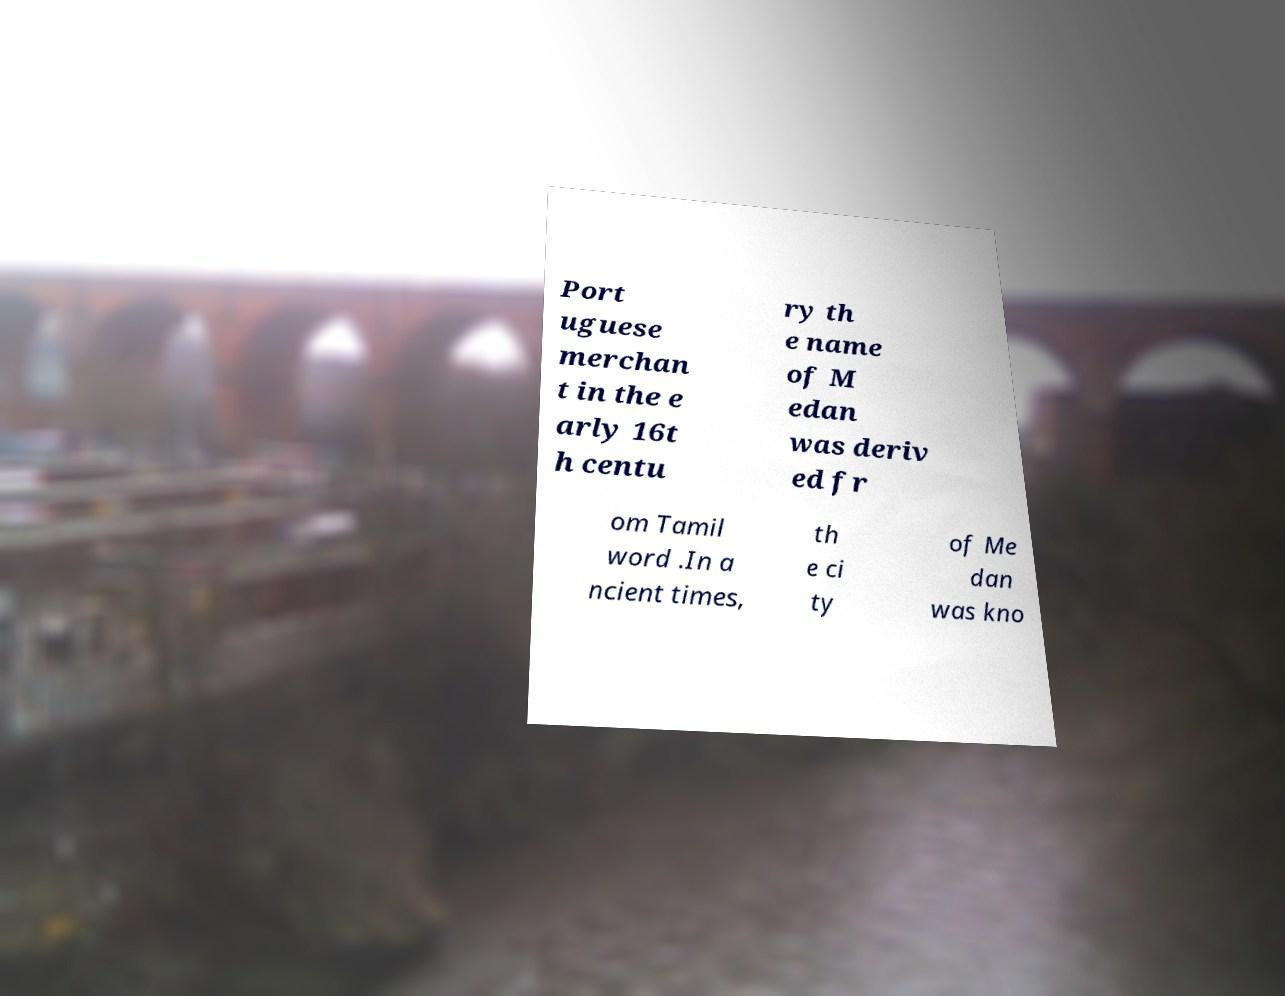I need the written content from this picture converted into text. Can you do that? Port uguese merchan t in the e arly 16t h centu ry th e name of M edan was deriv ed fr om Tamil word .In a ncient times, th e ci ty of Me dan was kno 